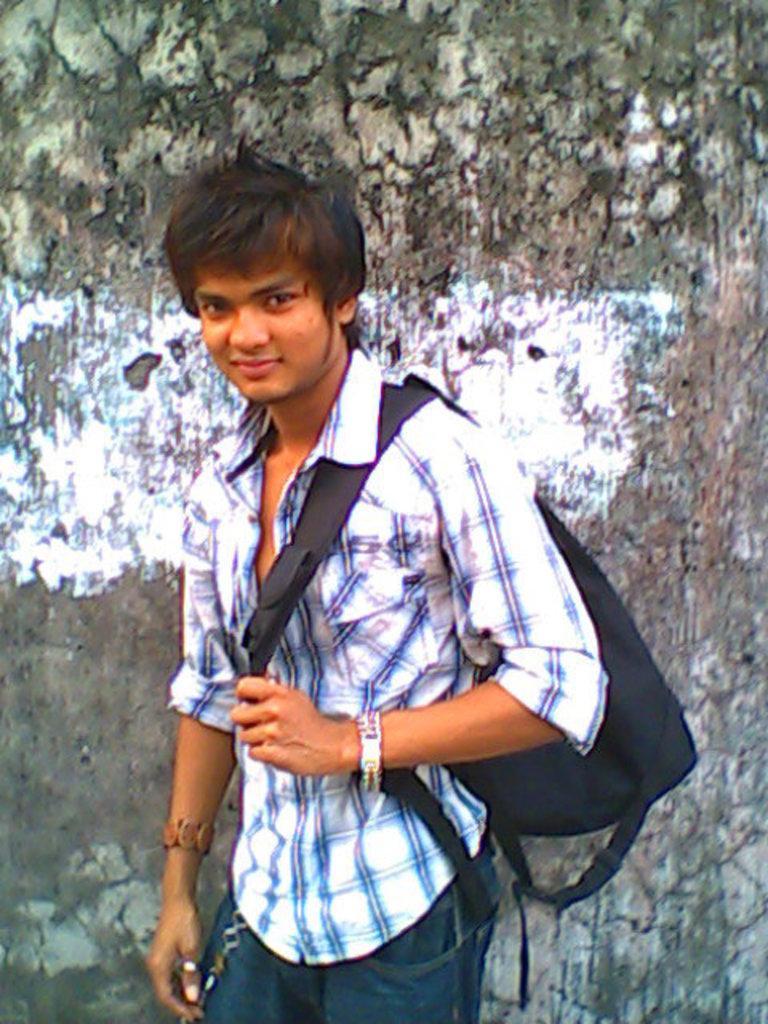In one or two sentences, can you explain what this image depicts? In the picture I can see a person standing and holding a black color bag on his back and there is a wall behind him. 